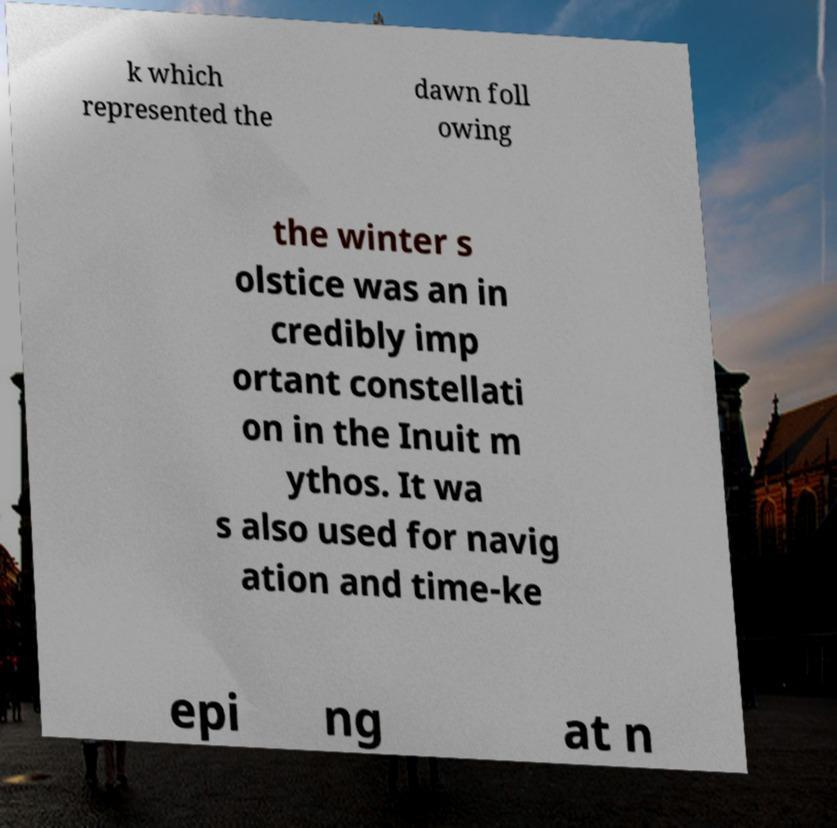Please read and relay the text visible in this image. What does it say? k which represented the dawn foll owing the winter s olstice was an in credibly imp ortant constellati on in the Inuit m ythos. It wa s also used for navig ation and time-ke epi ng at n 